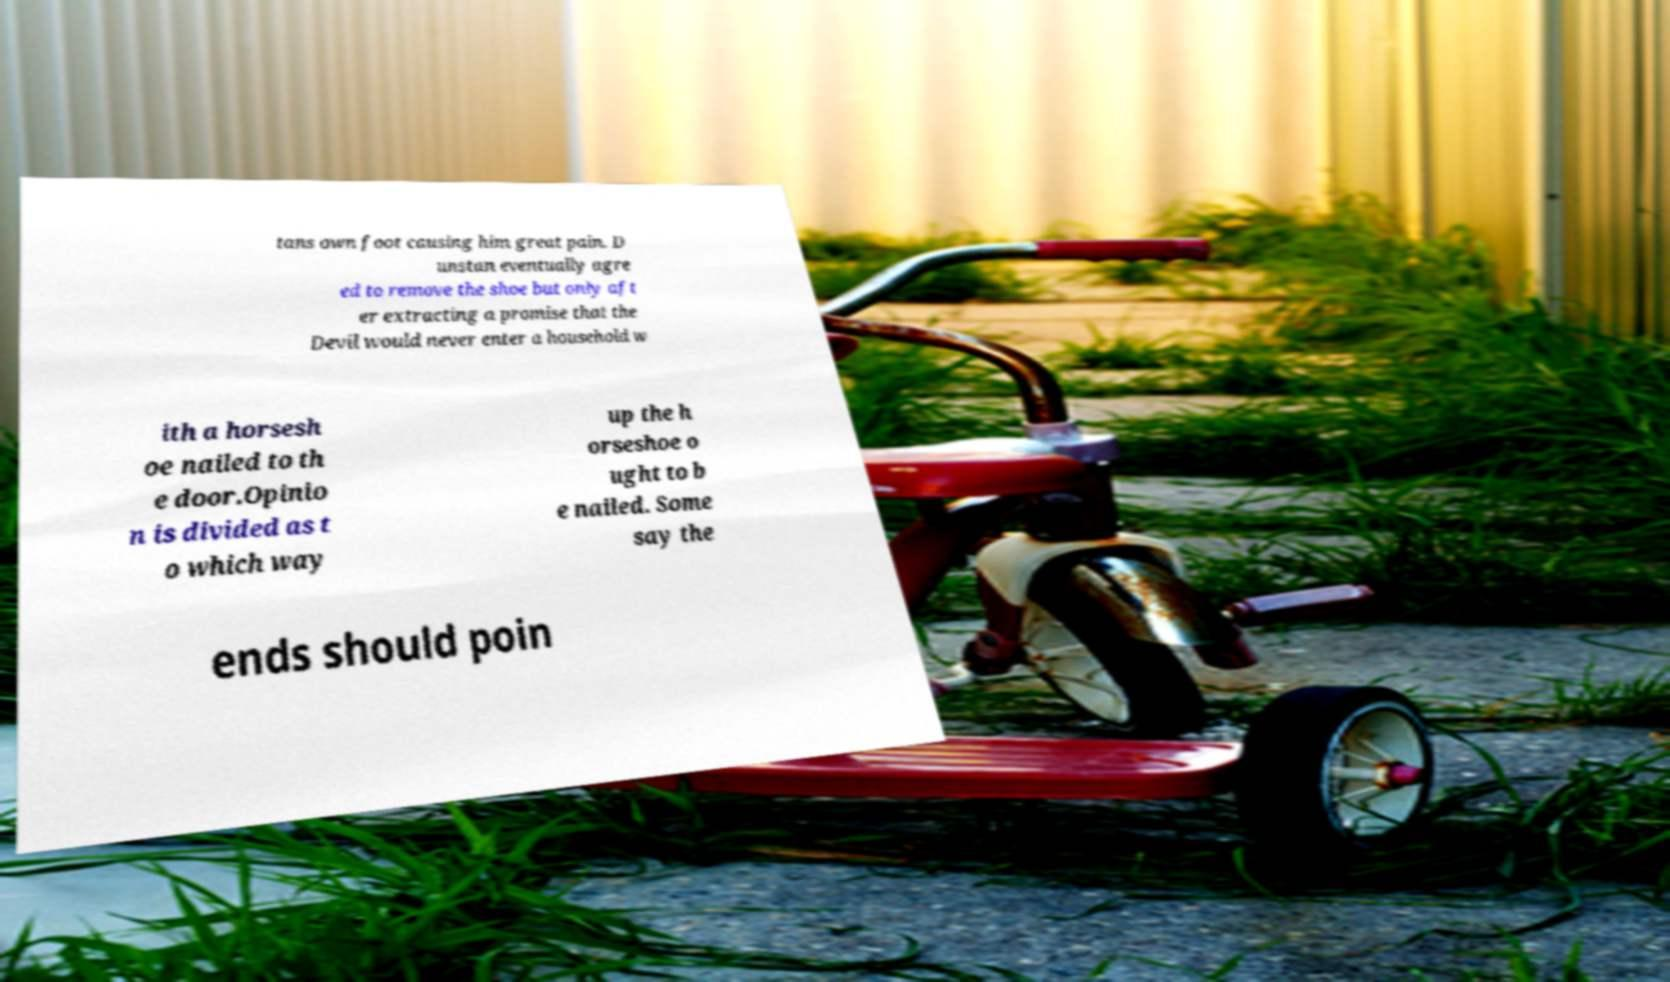Can you accurately transcribe the text from the provided image for me? tans own foot causing him great pain. D unstan eventually agre ed to remove the shoe but only aft er extracting a promise that the Devil would never enter a household w ith a horsesh oe nailed to th e door.Opinio n is divided as t o which way up the h orseshoe o ught to b e nailed. Some say the ends should poin 